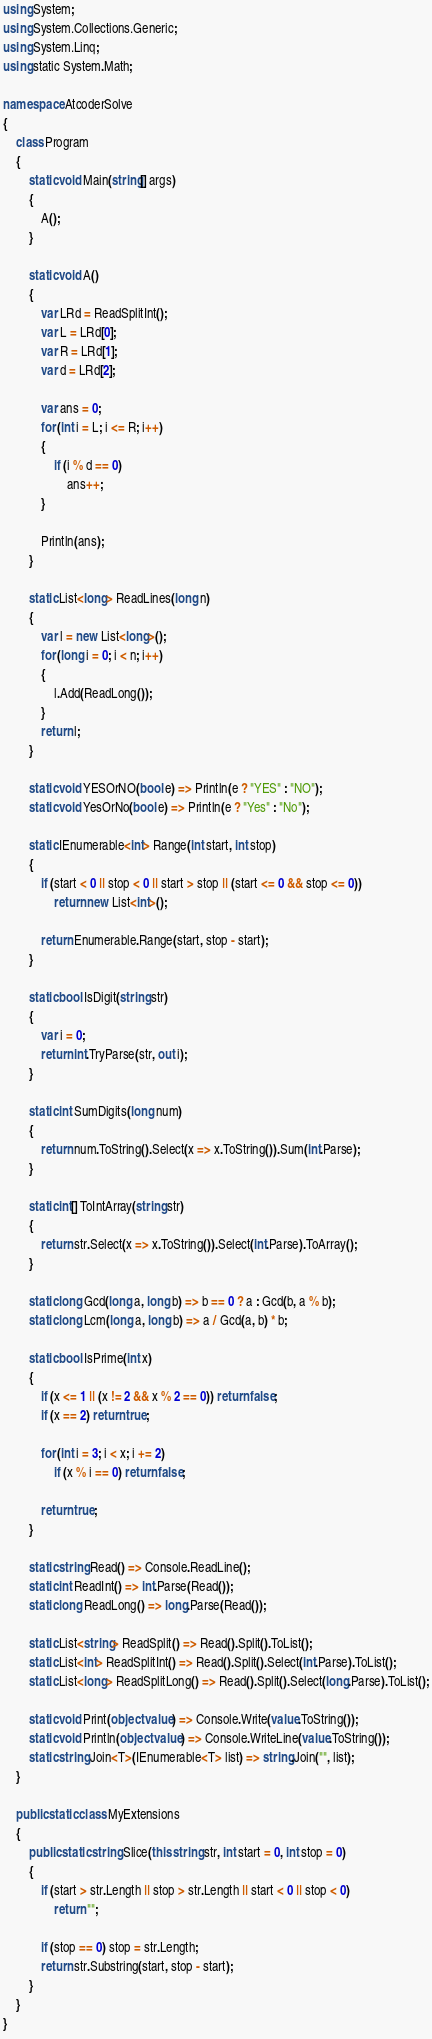<code> <loc_0><loc_0><loc_500><loc_500><_C#_>using System;
using System.Collections.Generic;
using System.Linq;
using static System.Math;

namespace AtcoderSolve
{
    class Program
    {
        static void Main(string[] args)
        {
            A();
        }

        static void A()
        {
            var LRd = ReadSplitInt();
            var L = LRd[0];
            var R = LRd[1];
            var d = LRd[2];

            var ans = 0;
            for (int i = L; i <= R; i++)
            {
                if (i % d == 0)
                    ans++;
            }

            Println(ans);
        }

        static List<long> ReadLines(long n)
        {
            var l = new List<long>();
            for (long i = 0; i < n; i++)
            {
                l.Add(ReadLong());
            }
            return l;
        }

        static void YESOrNO(bool e) => Println(e ? "YES" : "NO");
        static void YesOrNo(bool e) => Println(e ? "Yes" : "No");

        static IEnumerable<int> Range(int start, int stop)
        {
            if (start < 0 || stop < 0 || start > stop || (start <= 0 && stop <= 0))
                return new List<int>();

            return Enumerable.Range(start, stop - start);
        }

        static bool IsDigit(string str)
        {
            var i = 0;
            return int.TryParse(str, out i);
        }

        static int SumDigits(long num)
        {
            return num.ToString().Select(x => x.ToString()).Sum(int.Parse);
        }

        static int[] ToIntArray(string str)
        {
            return str.Select(x => x.ToString()).Select(int.Parse).ToArray();
        }

        static long Gcd(long a, long b) => b == 0 ? a : Gcd(b, a % b);
        static long Lcm(long a, long b) => a / Gcd(a, b) * b;

        static bool IsPrime(int x)
        {
            if (x <= 1 || (x != 2 && x % 2 == 0)) return false;
            if (x == 2) return true;

            for (int i = 3; i < x; i += 2)
                if (x % i == 0) return false;

            return true;
        }

        static string Read() => Console.ReadLine();
        static int ReadInt() => int.Parse(Read());
        static long ReadLong() => long.Parse(Read());

        static List<string> ReadSplit() => Read().Split().ToList();
        static List<int> ReadSplitInt() => Read().Split().Select(int.Parse).ToList();
        static List<long> ReadSplitLong() => Read().Split().Select(long.Parse).ToList();

        static void Print(object value) => Console.Write(value.ToString());
        static void Println(object value) => Console.WriteLine(value.ToString());
        static string Join<T>(IEnumerable<T> list) => string.Join("", list);
    }

    public static class MyExtensions
    {
        public static string Slice(this string str, int start = 0, int stop = 0)
        {
            if (start > str.Length || stop > str.Length || start < 0 || stop < 0)
                return "";

            if (stop == 0) stop = str.Length;
            return str.Substring(start, stop - start);
        }
    }
}

</code> 